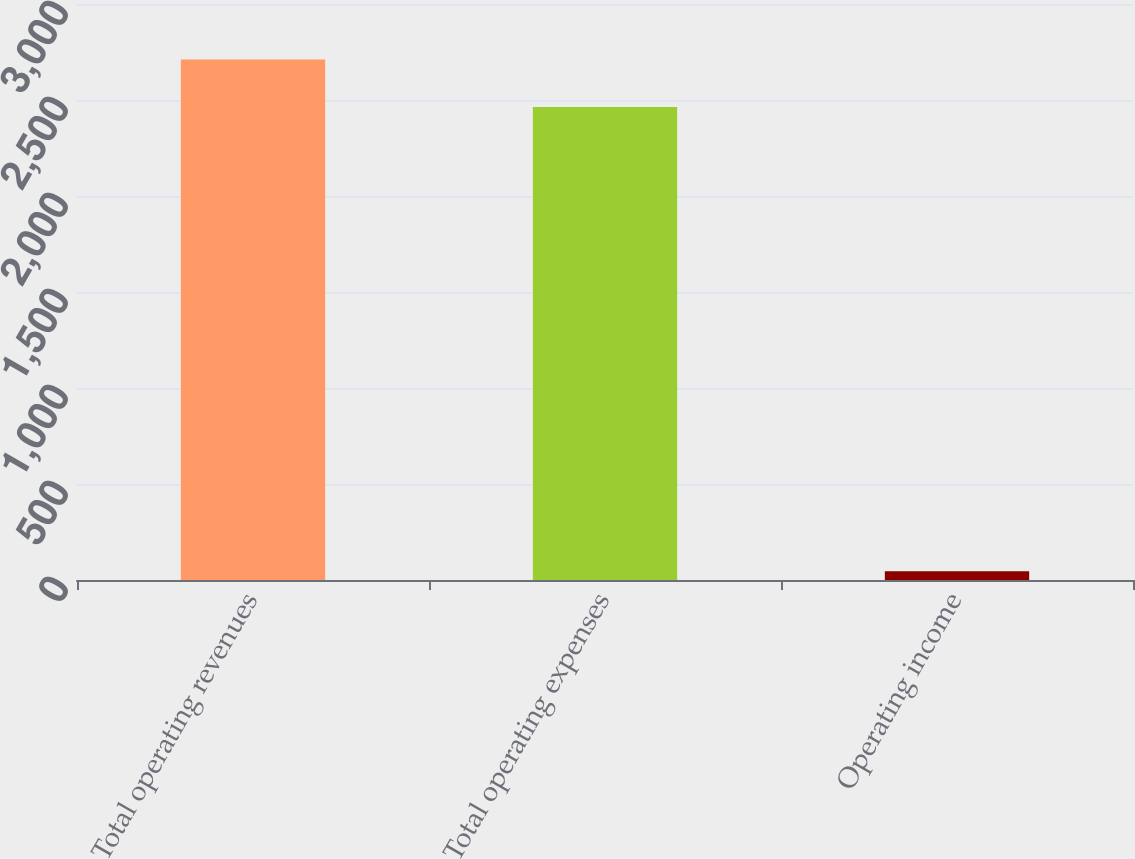<chart> <loc_0><loc_0><loc_500><loc_500><bar_chart><fcel>Total operating revenues<fcel>Total operating expenses<fcel>Operating income<nl><fcel>2710.4<fcel>2464<fcel>45<nl></chart> 